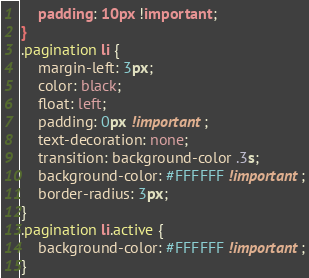Convert code to text. <code><loc_0><loc_0><loc_500><loc_500><_CSS_>	padding: 10px !important;
}
.pagination li {
    margin-left: 3px;
    color: black;
    float: left;
    padding: 0px !important;
    text-decoration: none;
    transition: background-color .3s;
    background-color: #FFFFFF !important;
    border-radius: 3px;
}
.pagination li.active {
    background-color: #FFFFFF !important;
}</code> 